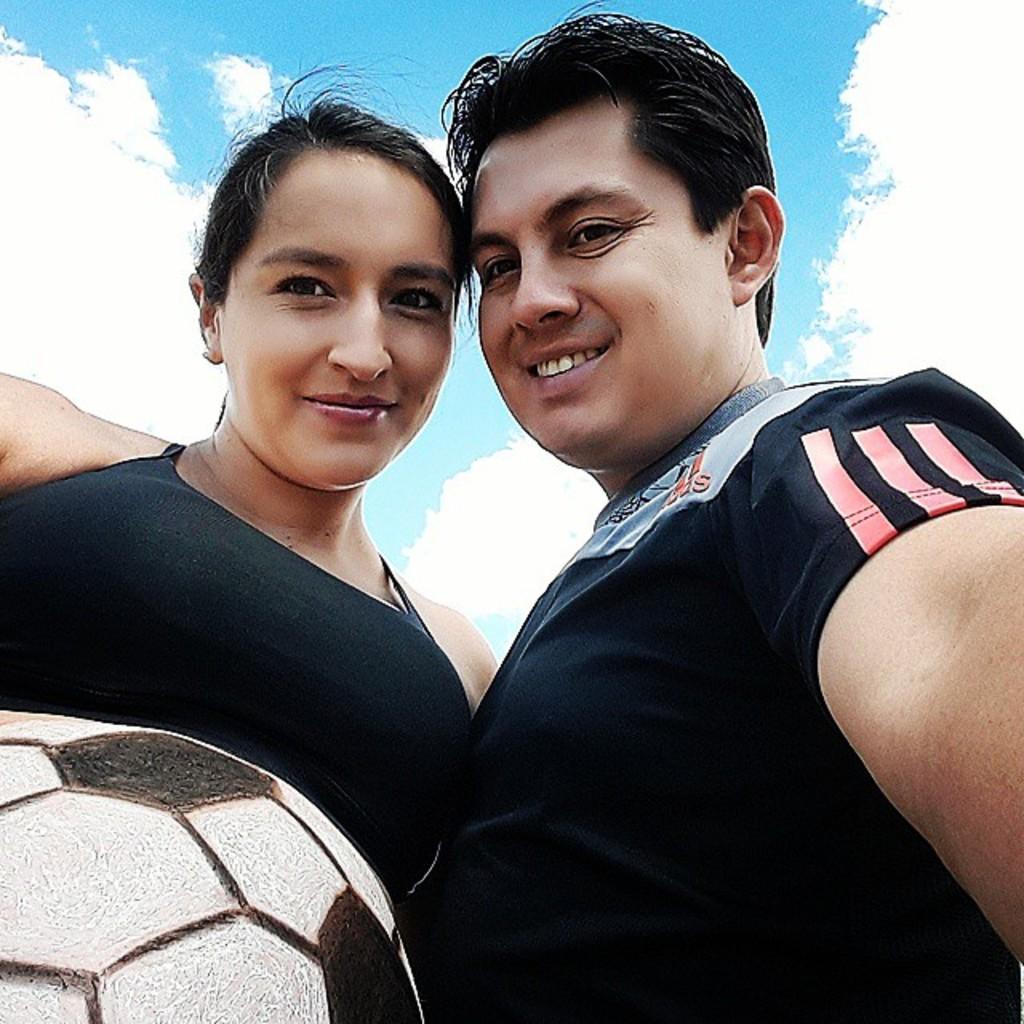Can you describe this image briefly? In this image I can see two persons and a ball. 